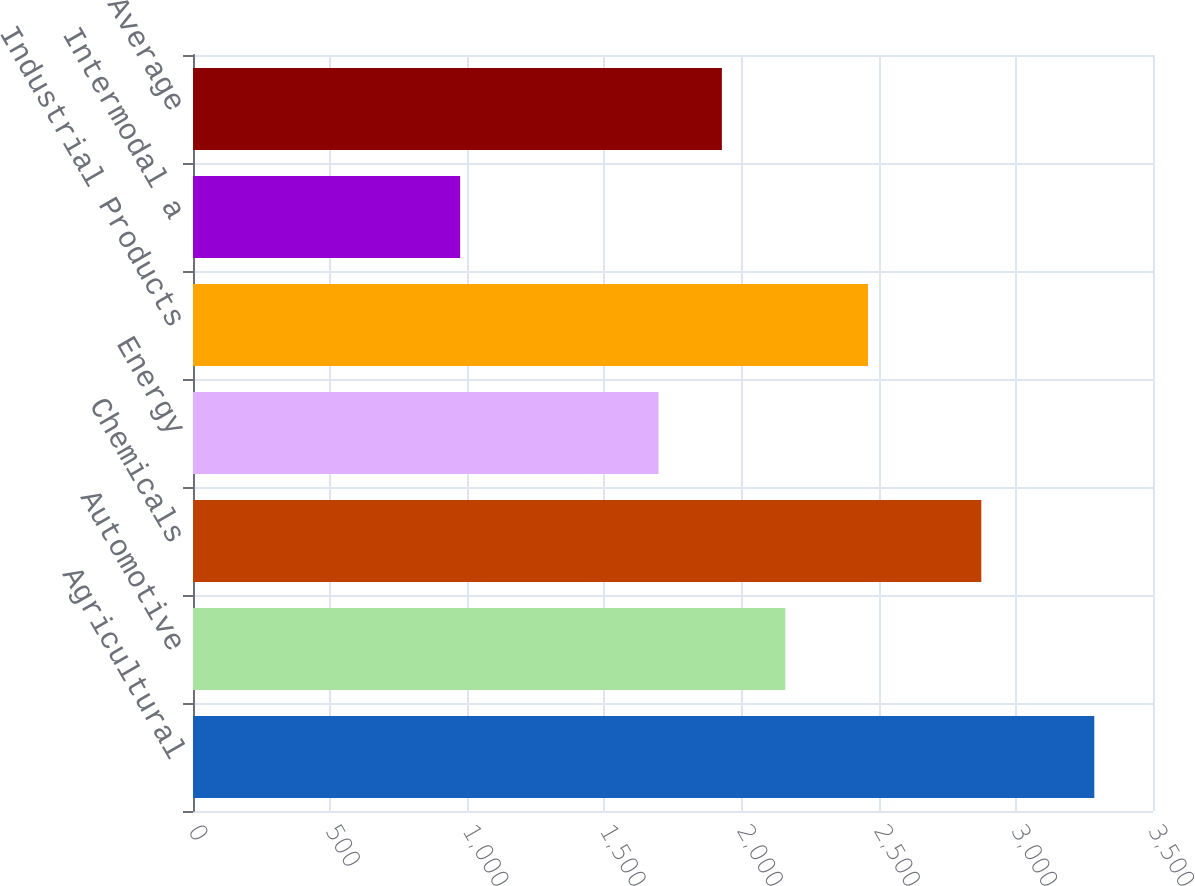Convert chart to OTSL. <chart><loc_0><loc_0><loc_500><loc_500><bar_chart><fcel>Agricultural<fcel>Automotive<fcel>Chemicals<fcel>Energy<fcel>Industrial Products<fcel>Intermodal a<fcel>Average<nl><fcel>3286<fcel>2159.4<fcel>2874<fcel>1697<fcel>2461<fcel>974<fcel>1928.2<nl></chart> 